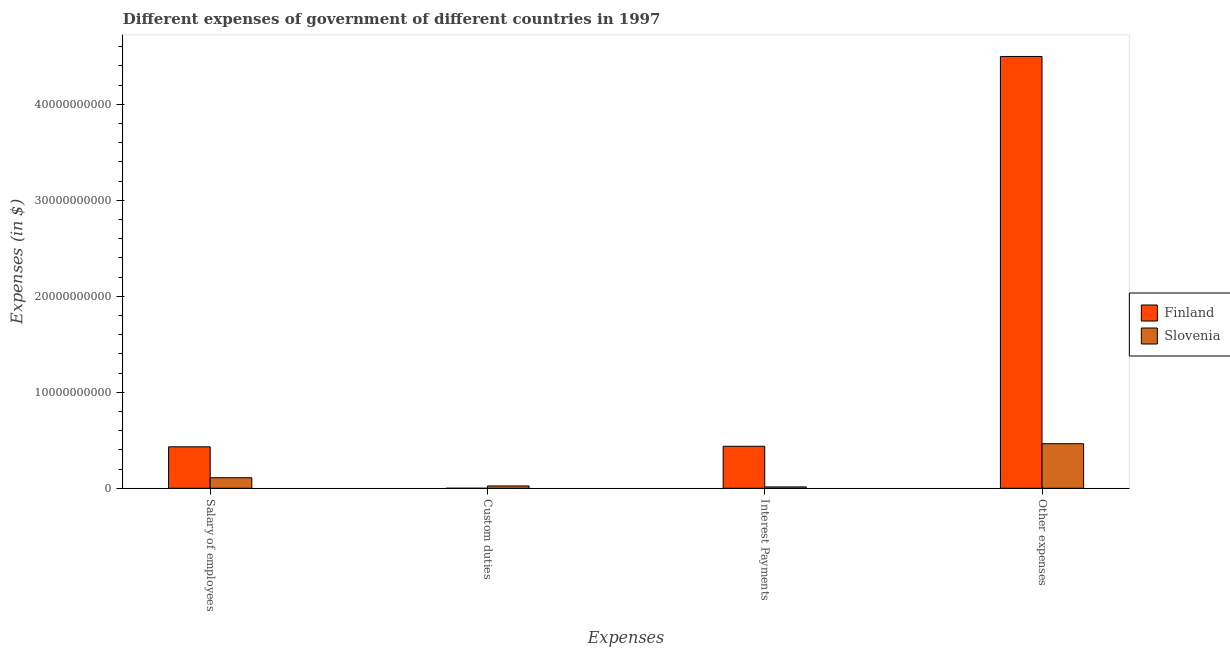Are the number of bars per tick equal to the number of legend labels?
Offer a terse response. Yes. How many bars are there on the 4th tick from the left?
Your answer should be very brief. 2. How many bars are there on the 1st tick from the right?
Provide a succinct answer. 2. What is the label of the 3rd group of bars from the left?
Your answer should be very brief. Interest Payments. What is the amount spent on interest payments in Slovenia?
Your answer should be very brief. 1.42e+08. Across all countries, what is the maximum amount spent on custom duties?
Provide a short and direct response. 2.44e+08. Across all countries, what is the minimum amount spent on interest payments?
Give a very brief answer. 1.42e+08. In which country was the amount spent on interest payments maximum?
Provide a succinct answer. Finland. In which country was the amount spent on custom duties minimum?
Your answer should be compact. Finland. What is the total amount spent on custom duties in the graph?
Your answer should be very brief. 2.45e+08. What is the difference between the amount spent on interest payments in Slovenia and that in Finland?
Your answer should be very brief. -4.24e+09. What is the difference between the amount spent on salary of employees in Slovenia and the amount spent on interest payments in Finland?
Keep it short and to the point. -3.28e+09. What is the average amount spent on salary of employees per country?
Offer a very short reply. 2.71e+09. What is the difference between the amount spent on other expenses and amount spent on salary of employees in Finland?
Provide a short and direct response. 4.07e+1. In how many countries, is the amount spent on custom duties greater than 12000000000 $?
Provide a short and direct response. 0. What is the ratio of the amount spent on other expenses in Finland to that in Slovenia?
Make the answer very short. 9.69. Is the amount spent on interest payments in Finland less than that in Slovenia?
Keep it short and to the point. No. What is the difference between the highest and the second highest amount spent on custom duties?
Provide a short and direct response. 2.43e+08. What is the difference between the highest and the lowest amount spent on interest payments?
Keep it short and to the point. 4.24e+09. In how many countries, is the amount spent on salary of employees greater than the average amount spent on salary of employees taken over all countries?
Offer a terse response. 1. Is the sum of the amount spent on salary of employees in Finland and Slovenia greater than the maximum amount spent on other expenses across all countries?
Make the answer very short. No. What does the 2nd bar from the left in Salary of employees represents?
Keep it short and to the point. Slovenia. Is it the case that in every country, the sum of the amount spent on salary of employees and amount spent on custom duties is greater than the amount spent on interest payments?
Make the answer very short. No. Are all the bars in the graph horizontal?
Provide a short and direct response. No. What is the difference between two consecutive major ticks on the Y-axis?
Give a very brief answer. 1.00e+1. Does the graph contain any zero values?
Your answer should be compact. No. Does the graph contain grids?
Provide a succinct answer. No. How are the legend labels stacked?
Provide a succinct answer. Vertical. What is the title of the graph?
Provide a succinct answer. Different expenses of government of different countries in 1997. What is the label or title of the X-axis?
Offer a terse response. Expenses. What is the label or title of the Y-axis?
Provide a short and direct response. Expenses (in $). What is the Expenses (in $) in Finland in Salary of employees?
Offer a very short reply. 4.32e+09. What is the Expenses (in $) in Slovenia in Salary of employees?
Provide a short and direct response. 1.10e+09. What is the Expenses (in $) in Finland in Custom duties?
Make the answer very short. 6.90e+05. What is the Expenses (in $) of Slovenia in Custom duties?
Provide a succinct answer. 2.44e+08. What is the Expenses (in $) of Finland in Interest Payments?
Give a very brief answer. 4.38e+09. What is the Expenses (in $) in Slovenia in Interest Payments?
Your answer should be compact. 1.42e+08. What is the Expenses (in $) in Finland in Other expenses?
Offer a terse response. 4.50e+1. What is the Expenses (in $) in Slovenia in Other expenses?
Make the answer very short. 4.64e+09. Across all Expenses, what is the maximum Expenses (in $) of Finland?
Your answer should be very brief. 4.50e+1. Across all Expenses, what is the maximum Expenses (in $) of Slovenia?
Offer a terse response. 4.64e+09. Across all Expenses, what is the minimum Expenses (in $) of Finland?
Provide a succinct answer. 6.90e+05. Across all Expenses, what is the minimum Expenses (in $) in Slovenia?
Your answer should be very brief. 1.42e+08. What is the total Expenses (in $) of Finland in the graph?
Offer a very short reply. 5.37e+1. What is the total Expenses (in $) of Slovenia in the graph?
Your response must be concise. 6.12e+09. What is the difference between the Expenses (in $) in Finland in Salary of employees and that in Custom duties?
Provide a succinct answer. 4.32e+09. What is the difference between the Expenses (in $) of Slovenia in Salary of employees and that in Custom duties?
Provide a short and direct response. 8.53e+08. What is the difference between the Expenses (in $) of Finland in Salary of employees and that in Interest Payments?
Ensure brevity in your answer.  -5.80e+07. What is the difference between the Expenses (in $) in Slovenia in Salary of employees and that in Interest Payments?
Offer a very short reply. 9.55e+08. What is the difference between the Expenses (in $) in Finland in Salary of employees and that in Other expenses?
Offer a terse response. -4.07e+1. What is the difference between the Expenses (in $) of Slovenia in Salary of employees and that in Other expenses?
Keep it short and to the point. -3.54e+09. What is the difference between the Expenses (in $) in Finland in Custom duties and that in Interest Payments?
Ensure brevity in your answer.  -4.38e+09. What is the difference between the Expenses (in $) in Slovenia in Custom duties and that in Interest Payments?
Offer a terse response. 1.02e+08. What is the difference between the Expenses (in $) of Finland in Custom duties and that in Other expenses?
Your answer should be very brief. -4.50e+1. What is the difference between the Expenses (in $) of Slovenia in Custom duties and that in Other expenses?
Your answer should be compact. -4.40e+09. What is the difference between the Expenses (in $) of Finland in Interest Payments and that in Other expenses?
Keep it short and to the point. -4.06e+1. What is the difference between the Expenses (in $) in Slovenia in Interest Payments and that in Other expenses?
Provide a succinct answer. -4.50e+09. What is the difference between the Expenses (in $) in Finland in Salary of employees and the Expenses (in $) in Slovenia in Custom duties?
Make the answer very short. 4.08e+09. What is the difference between the Expenses (in $) in Finland in Salary of employees and the Expenses (in $) in Slovenia in Interest Payments?
Make the answer very short. 4.18e+09. What is the difference between the Expenses (in $) in Finland in Salary of employees and the Expenses (in $) in Slovenia in Other expenses?
Ensure brevity in your answer.  -3.21e+08. What is the difference between the Expenses (in $) of Finland in Custom duties and the Expenses (in $) of Slovenia in Interest Payments?
Provide a succinct answer. -1.42e+08. What is the difference between the Expenses (in $) in Finland in Custom duties and the Expenses (in $) in Slovenia in Other expenses?
Your response must be concise. -4.64e+09. What is the difference between the Expenses (in $) in Finland in Interest Payments and the Expenses (in $) in Slovenia in Other expenses?
Offer a very short reply. -2.63e+08. What is the average Expenses (in $) of Finland per Expenses?
Ensure brevity in your answer.  1.34e+1. What is the average Expenses (in $) in Slovenia per Expenses?
Offer a terse response. 1.53e+09. What is the difference between the Expenses (in $) of Finland and Expenses (in $) of Slovenia in Salary of employees?
Your answer should be compact. 3.22e+09. What is the difference between the Expenses (in $) in Finland and Expenses (in $) in Slovenia in Custom duties?
Provide a succinct answer. -2.43e+08. What is the difference between the Expenses (in $) of Finland and Expenses (in $) of Slovenia in Interest Payments?
Ensure brevity in your answer.  4.24e+09. What is the difference between the Expenses (in $) of Finland and Expenses (in $) of Slovenia in Other expenses?
Provide a short and direct response. 4.03e+1. What is the ratio of the Expenses (in $) of Finland in Salary of employees to that in Custom duties?
Your answer should be very brief. 6260.87. What is the ratio of the Expenses (in $) in Slovenia in Salary of employees to that in Custom duties?
Offer a very short reply. 4.49. What is the ratio of the Expenses (in $) of Slovenia in Salary of employees to that in Interest Payments?
Ensure brevity in your answer.  7.71. What is the ratio of the Expenses (in $) in Finland in Salary of employees to that in Other expenses?
Your answer should be compact. 0.1. What is the ratio of the Expenses (in $) in Slovenia in Salary of employees to that in Other expenses?
Give a very brief answer. 0.24. What is the ratio of the Expenses (in $) of Slovenia in Custom duties to that in Interest Payments?
Your answer should be compact. 1.72. What is the ratio of the Expenses (in $) in Slovenia in Custom duties to that in Other expenses?
Give a very brief answer. 0.05. What is the ratio of the Expenses (in $) in Finland in Interest Payments to that in Other expenses?
Keep it short and to the point. 0.1. What is the ratio of the Expenses (in $) in Slovenia in Interest Payments to that in Other expenses?
Offer a very short reply. 0.03. What is the difference between the highest and the second highest Expenses (in $) of Finland?
Give a very brief answer. 4.06e+1. What is the difference between the highest and the second highest Expenses (in $) of Slovenia?
Keep it short and to the point. 3.54e+09. What is the difference between the highest and the lowest Expenses (in $) of Finland?
Your answer should be compact. 4.50e+1. What is the difference between the highest and the lowest Expenses (in $) of Slovenia?
Your answer should be very brief. 4.50e+09. 